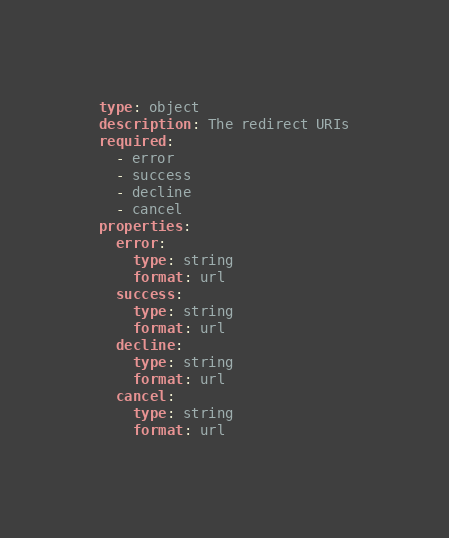Convert code to text. <code><loc_0><loc_0><loc_500><loc_500><_YAML_>type: object
description: The redirect URIs
required:
  - error
  - success
  - decline
  - cancel
properties:
  error:
    type: string
    format: url
  success:
    type: string
    format: url
  decline:
    type: string
    format: url
  cancel:
    type: string
    format: url
</code> 